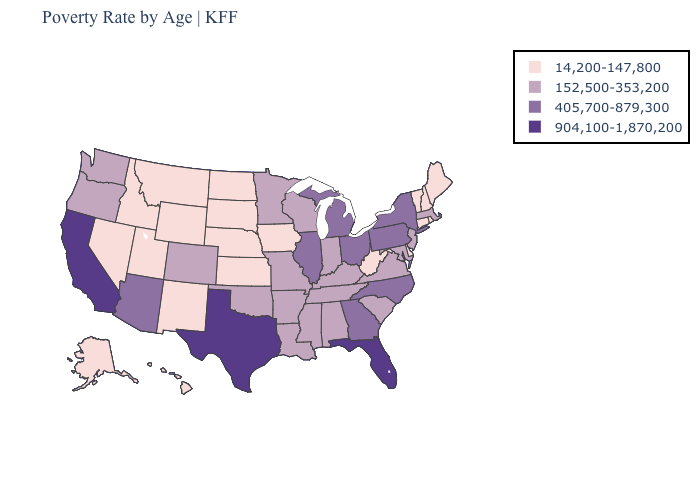What is the highest value in the USA?
Short answer required. 904,100-1,870,200. Among the states that border Oregon , which have the highest value?
Quick response, please. California. Name the states that have a value in the range 152,500-353,200?
Short answer required. Alabama, Arkansas, Colorado, Indiana, Kentucky, Louisiana, Maryland, Massachusetts, Minnesota, Mississippi, Missouri, New Jersey, Oklahoma, Oregon, South Carolina, Tennessee, Virginia, Washington, Wisconsin. Among the states that border Illinois , which have the lowest value?
Answer briefly. Iowa. Among the states that border Ohio , which have the lowest value?
Answer briefly. West Virginia. Name the states that have a value in the range 14,200-147,800?
Keep it brief. Alaska, Connecticut, Delaware, Hawaii, Idaho, Iowa, Kansas, Maine, Montana, Nebraska, Nevada, New Hampshire, New Mexico, North Dakota, Rhode Island, South Dakota, Utah, Vermont, West Virginia, Wyoming. Does Connecticut have a higher value than Kentucky?
Give a very brief answer. No. What is the lowest value in the West?
Keep it brief. 14,200-147,800. Does Florida have a lower value than Nevada?
Concise answer only. No. What is the value of New Hampshire?
Concise answer only. 14,200-147,800. What is the value of Tennessee?
Concise answer only. 152,500-353,200. Does Tennessee have the highest value in the USA?
Short answer required. No. What is the value of South Dakota?
Keep it brief. 14,200-147,800. What is the value of Texas?
Write a very short answer. 904,100-1,870,200. Does Texas have the highest value in the USA?
Answer briefly. Yes. 